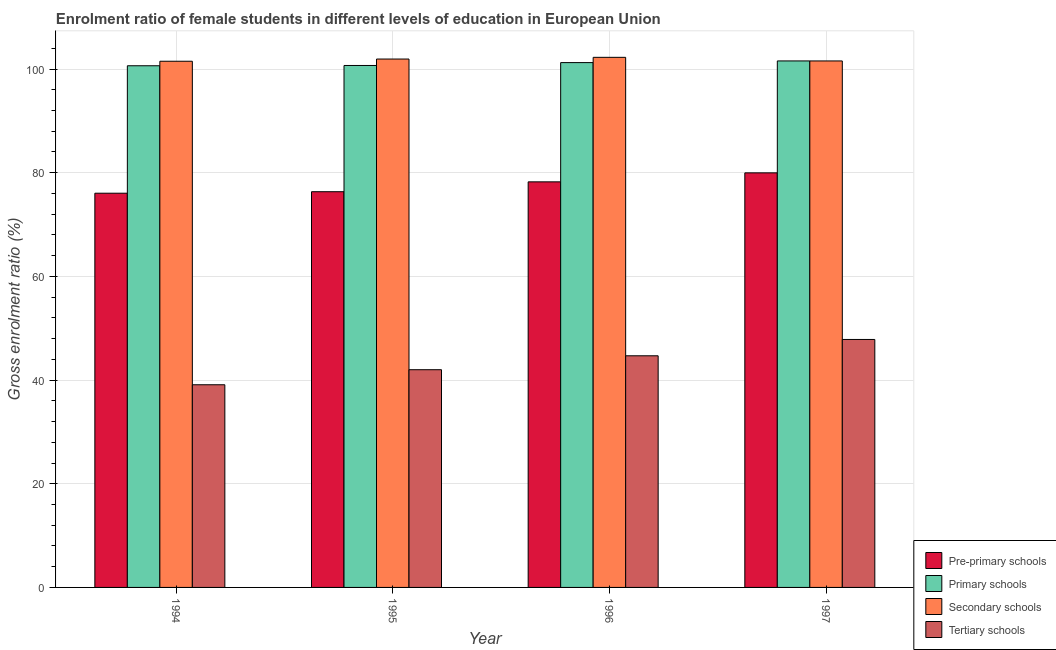How many different coloured bars are there?
Provide a short and direct response. 4. Are the number of bars per tick equal to the number of legend labels?
Provide a short and direct response. Yes. How many bars are there on the 1st tick from the right?
Offer a very short reply. 4. What is the label of the 2nd group of bars from the left?
Ensure brevity in your answer.  1995. In how many cases, is the number of bars for a given year not equal to the number of legend labels?
Make the answer very short. 0. What is the gross enrolment ratio(male) in secondary schools in 1996?
Make the answer very short. 102.26. Across all years, what is the maximum gross enrolment ratio(male) in pre-primary schools?
Offer a terse response. 79.97. Across all years, what is the minimum gross enrolment ratio(male) in pre-primary schools?
Offer a terse response. 76.05. What is the total gross enrolment ratio(male) in primary schools in the graph?
Give a very brief answer. 404.13. What is the difference between the gross enrolment ratio(male) in secondary schools in 1994 and that in 1996?
Ensure brevity in your answer.  -0.75. What is the difference between the gross enrolment ratio(male) in primary schools in 1994 and the gross enrolment ratio(male) in secondary schools in 1996?
Ensure brevity in your answer.  -0.61. What is the average gross enrolment ratio(male) in tertiary schools per year?
Provide a succinct answer. 43.4. In how many years, is the gross enrolment ratio(male) in tertiary schools greater than 76 %?
Offer a terse response. 0. What is the ratio of the gross enrolment ratio(male) in secondary schools in 1994 to that in 1996?
Offer a very short reply. 0.99. Is the gross enrolment ratio(male) in pre-primary schools in 1994 less than that in 1997?
Your answer should be very brief. Yes. Is the difference between the gross enrolment ratio(male) in primary schools in 1994 and 1995 greater than the difference between the gross enrolment ratio(male) in secondary schools in 1994 and 1995?
Your answer should be compact. No. What is the difference between the highest and the second highest gross enrolment ratio(male) in secondary schools?
Give a very brief answer. 0.33. What is the difference between the highest and the lowest gross enrolment ratio(male) in tertiary schools?
Offer a very short reply. 8.74. Is the sum of the gross enrolment ratio(male) in primary schools in 1994 and 1997 greater than the maximum gross enrolment ratio(male) in pre-primary schools across all years?
Provide a short and direct response. Yes. What does the 3rd bar from the left in 1995 represents?
Keep it short and to the point. Secondary schools. What does the 3rd bar from the right in 1994 represents?
Your answer should be compact. Primary schools. Are all the bars in the graph horizontal?
Ensure brevity in your answer.  No. How many years are there in the graph?
Provide a succinct answer. 4. What is the difference between two consecutive major ticks on the Y-axis?
Ensure brevity in your answer.  20. Does the graph contain grids?
Offer a terse response. Yes. Where does the legend appear in the graph?
Your answer should be very brief. Bottom right. How many legend labels are there?
Give a very brief answer. 4. What is the title of the graph?
Provide a short and direct response. Enrolment ratio of female students in different levels of education in European Union. Does "Regional development banks" appear as one of the legend labels in the graph?
Give a very brief answer. No. What is the label or title of the X-axis?
Keep it short and to the point. Year. What is the label or title of the Y-axis?
Offer a terse response. Gross enrolment ratio (%). What is the Gross enrolment ratio (%) in Pre-primary schools in 1994?
Provide a succinct answer. 76.05. What is the Gross enrolment ratio (%) in Primary schools in 1994?
Your answer should be compact. 100.63. What is the Gross enrolment ratio (%) in Secondary schools in 1994?
Your answer should be very brief. 101.51. What is the Gross enrolment ratio (%) of Tertiary schools in 1994?
Your answer should be compact. 39.1. What is the Gross enrolment ratio (%) in Pre-primary schools in 1995?
Ensure brevity in your answer.  76.34. What is the Gross enrolment ratio (%) of Primary schools in 1995?
Offer a very short reply. 100.69. What is the Gross enrolment ratio (%) of Secondary schools in 1995?
Your answer should be very brief. 101.93. What is the Gross enrolment ratio (%) of Tertiary schools in 1995?
Your response must be concise. 42. What is the Gross enrolment ratio (%) in Pre-primary schools in 1996?
Make the answer very short. 78.24. What is the Gross enrolment ratio (%) of Primary schools in 1996?
Give a very brief answer. 101.24. What is the Gross enrolment ratio (%) in Secondary schools in 1996?
Your answer should be very brief. 102.26. What is the Gross enrolment ratio (%) of Tertiary schools in 1996?
Provide a short and direct response. 44.68. What is the Gross enrolment ratio (%) in Pre-primary schools in 1997?
Give a very brief answer. 79.97. What is the Gross enrolment ratio (%) of Primary schools in 1997?
Your response must be concise. 101.57. What is the Gross enrolment ratio (%) in Secondary schools in 1997?
Give a very brief answer. 101.56. What is the Gross enrolment ratio (%) in Tertiary schools in 1997?
Your response must be concise. 47.83. Across all years, what is the maximum Gross enrolment ratio (%) in Pre-primary schools?
Keep it short and to the point. 79.97. Across all years, what is the maximum Gross enrolment ratio (%) in Primary schools?
Your response must be concise. 101.57. Across all years, what is the maximum Gross enrolment ratio (%) of Secondary schools?
Your response must be concise. 102.26. Across all years, what is the maximum Gross enrolment ratio (%) in Tertiary schools?
Ensure brevity in your answer.  47.83. Across all years, what is the minimum Gross enrolment ratio (%) in Pre-primary schools?
Provide a succinct answer. 76.05. Across all years, what is the minimum Gross enrolment ratio (%) in Primary schools?
Keep it short and to the point. 100.63. Across all years, what is the minimum Gross enrolment ratio (%) in Secondary schools?
Offer a terse response. 101.51. Across all years, what is the minimum Gross enrolment ratio (%) in Tertiary schools?
Keep it short and to the point. 39.1. What is the total Gross enrolment ratio (%) in Pre-primary schools in the graph?
Offer a very short reply. 310.6. What is the total Gross enrolment ratio (%) of Primary schools in the graph?
Offer a very short reply. 404.13. What is the total Gross enrolment ratio (%) of Secondary schools in the graph?
Your answer should be compact. 407.26. What is the total Gross enrolment ratio (%) of Tertiary schools in the graph?
Your answer should be very brief. 173.61. What is the difference between the Gross enrolment ratio (%) in Pre-primary schools in 1994 and that in 1995?
Your response must be concise. -0.29. What is the difference between the Gross enrolment ratio (%) of Primary schools in 1994 and that in 1995?
Make the answer very short. -0.05. What is the difference between the Gross enrolment ratio (%) in Secondary schools in 1994 and that in 1995?
Your answer should be very brief. -0.42. What is the difference between the Gross enrolment ratio (%) in Tertiary schools in 1994 and that in 1995?
Provide a succinct answer. -2.9. What is the difference between the Gross enrolment ratio (%) in Pre-primary schools in 1994 and that in 1996?
Your response must be concise. -2.19. What is the difference between the Gross enrolment ratio (%) in Primary schools in 1994 and that in 1996?
Your answer should be compact. -0.61. What is the difference between the Gross enrolment ratio (%) in Secondary schools in 1994 and that in 1996?
Keep it short and to the point. -0.75. What is the difference between the Gross enrolment ratio (%) of Tertiary schools in 1994 and that in 1996?
Offer a terse response. -5.59. What is the difference between the Gross enrolment ratio (%) in Pre-primary schools in 1994 and that in 1997?
Your response must be concise. -3.93. What is the difference between the Gross enrolment ratio (%) in Primary schools in 1994 and that in 1997?
Ensure brevity in your answer.  -0.93. What is the difference between the Gross enrolment ratio (%) in Secondary schools in 1994 and that in 1997?
Make the answer very short. -0.06. What is the difference between the Gross enrolment ratio (%) in Tertiary schools in 1994 and that in 1997?
Your response must be concise. -8.74. What is the difference between the Gross enrolment ratio (%) of Pre-primary schools in 1995 and that in 1996?
Offer a very short reply. -1.9. What is the difference between the Gross enrolment ratio (%) in Primary schools in 1995 and that in 1996?
Provide a short and direct response. -0.56. What is the difference between the Gross enrolment ratio (%) of Secondary schools in 1995 and that in 1996?
Your answer should be compact. -0.33. What is the difference between the Gross enrolment ratio (%) of Tertiary schools in 1995 and that in 1996?
Provide a short and direct response. -2.68. What is the difference between the Gross enrolment ratio (%) in Pre-primary schools in 1995 and that in 1997?
Provide a short and direct response. -3.64. What is the difference between the Gross enrolment ratio (%) in Primary schools in 1995 and that in 1997?
Keep it short and to the point. -0.88. What is the difference between the Gross enrolment ratio (%) in Secondary schools in 1995 and that in 1997?
Your answer should be very brief. 0.37. What is the difference between the Gross enrolment ratio (%) of Tertiary schools in 1995 and that in 1997?
Ensure brevity in your answer.  -5.83. What is the difference between the Gross enrolment ratio (%) in Pre-primary schools in 1996 and that in 1997?
Keep it short and to the point. -1.73. What is the difference between the Gross enrolment ratio (%) in Primary schools in 1996 and that in 1997?
Offer a terse response. -0.32. What is the difference between the Gross enrolment ratio (%) in Secondary schools in 1996 and that in 1997?
Offer a terse response. 0.7. What is the difference between the Gross enrolment ratio (%) of Tertiary schools in 1996 and that in 1997?
Ensure brevity in your answer.  -3.15. What is the difference between the Gross enrolment ratio (%) of Pre-primary schools in 1994 and the Gross enrolment ratio (%) of Primary schools in 1995?
Provide a short and direct response. -24.64. What is the difference between the Gross enrolment ratio (%) in Pre-primary schools in 1994 and the Gross enrolment ratio (%) in Secondary schools in 1995?
Offer a terse response. -25.88. What is the difference between the Gross enrolment ratio (%) in Pre-primary schools in 1994 and the Gross enrolment ratio (%) in Tertiary schools in 1995?
Ensure brevity in your answer.  34.05. What is the difference between the Gross enrolment ratio (%) in Primary schools in 1994 and the Gross enrolment ratio (%) in Secondary schools in 1995?
Provide a succinct answer. -1.3. What is the difference between the Gross enrolment ratio (%) of Primary schools in 1994 and the Gross enrolment ratio (%) of Tertiary schools in 1995?
Your answer should be very brief. 58.63. What is the difference between the Gross enrolment ratio (%) in Secondary schools in 1994 and the Gross enrolment ratio (%) in Tertiary schools in 1995?
Ensure brevity in your answer.  59.51. What is the difference between the Gross enrolment ratio (%) of Pre-primary schools in 1994 and the Gross enrolment ratio (%) of Primary schools in 1996?
Make the answer very short. -25.2. What is the difference between the Gross enrolment ratio (%) in Pre-primary schools in 1994 and the Gross enrolment ratio (%) in Secondary schools in 1996?
Keep it short and to the point. -26.21. What is the difference between the Gross enrolment ratio (%) of Pre-primary schools in 1994 and the Gross enrolment ratio (%) of Tertiary schools in 1996?
Offer a very short reply. 31.36. What is the difference between the Gross enrolment ratio (%) in Primary schools in 1994 and the Gross enrolment ratio (%) in Secondary schools in 1996?
Keep it short and to the point. -1.63. What is the difference between the Gross enrolment ratio (%) in Primary schools in 1994 and the Gross enrolment ratio (%) in Tertiary schools in 1996?
Your answer should be compact. 55.95. What is the difference between the Gross enrolment ratio (%) of Secondary schools in 1994 and the Gross enrolment ratio (%) of Tertiary schools in 1996?
Make the answer very short. 56.82. What is the difference between the Gross enrolment ratio (%) in Pre-primary schools in 1994 and the Gross enrolment ratio (%) in Primary schools in 1997?
Keep it short and to the point. -25.52. What is the difference between the Gross enrolment ratio (%) in Pre-primary schools in 1994 and the Gross enrolment ratio (%) in Secondary schools in 1997?
Provide a short and direct response. -25.51. What is the difference between the Gross enrolment ratio (%) of Pre-primary schools in 1994 and the Gross enrolment ratio (%) of Tertiary schools in 1997?
Provide a succinct answer. 28.21. What is the difference between the Gross enrolment ratio (%) in Primary schools in 1994 and the Gross enrolment ratio (%) in Secondary schools in 1997?
Ensure brevity in your answer.  -0.93. What is the difference between the Gross enrolment ratio (%) of Primary schools in 1994 and the Gross enrolment ratio (%) of Tertiary schools in 1997?
Give a very brief answer. 52.8. What is the difference between the Gross enrolment ratio (%) of Secondary schools in 1994 and the Gross enrolment ratio (%) of Tertiary schools in 1997?
Provide a short and direct response. 53.67. What is the difference between the Gross enrolment ratio (%) in Pre-primary schools in 1995 and the Gross enrolment ratio (%) in Primary schools in 1996?
Keep it short and to the point. -24.91. What is the difference between the Gross enrolment ratio (%) of Pre-primary schools in 1995 and the Gross enrolment ratio (%) of Secondary schools in 1996?
Offer a terse response. -25.92. What is the difference between the Gross enrolment ratio (%) in Pre-primary schools in 1995 and the Gross enrolment ratio (%) in Tertiary schools in 1996?
Give a very brief answer. 31.65. What is the difference between the Gross enrolment ratio (%) of Primary schools in 1995 and the Gross enrolment ratio (%) of Secondary schools in 1996?
Give a very brief answer. -1.57. What is the difference between the Gross enrolment ratio (%) in Primary schools in 1995 and the Gross enrolment ratio (%) in Tertiary schools in 1996?
Give a very brief answer. 56. What is the difference between the Gross enrolment ratio (%) in Secondary schools in 1995 and the Gross enrolment ratio (%) in Tertiary schools in 1996?
Ensure brevity in your answer.  57.25. What is the difference between the Gross enrolment ratio (%) in Pre-primary schools in 1995 and the Gross enrolment ratio (%) in Primary schools in 1997?
Offer a terse response. -25.23. What is the difference between the Gross enrolment ratio (%) of Pre-primary schools in 1995 and the Gross enrolment ratio (%) of Secondary schools in 1997?
Offer a very short reply. -25.23. What is the difference between the Gross enrolment ratio (%) of Pre-primary schools in 1995 and the Gross enrolment ratio (%) of Tertiary schools in 1997?
Your answer should be compact. 28.5. What is the difference between the Gross enrolment ratio (%) of Primary schools in 1995 and the Gross enrolment ratio (%) of Secondary schools in 1997?
Your answer should be compact. -0.87. What is the difference between the Gross enrolment ratio (%) in Primary schools in 1995 and the Gross enrolment ratio (%) in Tertiary schools in 1997?
Offer a very short reply. 52.85. What is the difference between the Gross enrolment ratio (%) of Secondary schools in 1995 and the Gross enrolment ratio (%) of Tertiary schools in 1997?
Offer a terse response. 54.1. What is the difference between the Gross enrolment ratio (%) in Pre-primary schools in 1996 and the Gross enrolment ratio (%) in Primary schools in 1997?
Your answer should be very brief. -23.33. What is the difference between the Gross enrolment ratio (%) in Pre-primary schools in 1996 and the Gross enrolment ratio (%) in Secondary schools in 1997?
Your answer should be compact. -23.32. What is the difference between the Gross enrolment ratio (%) of Pre-primary schools in 1996 and the Gross enrolment ratio (%) of Tertiary schools in 1997?
Provide a short and direct response. 30.41. What is the difference between the Gross enrolment ratio (%) in Primary schools in 1996 and the Gross enrolment ratio (%) in Secondary schools in 1997?
Provide a short and direct response. -0.32. What is the difference between the Gross enrolment ratio (%) of Primary schools in 1996 and the Gross enrolment ratio (%) of Tertiary schools in 1997?
Keep it short and to the point. 53.41. What is the difference between the Gross enrolment ratio (%) in Secondary schools in 1996 and the Gross enrolment ratio (%) in Tertiary schools in 1997?
Your answer should be compact. 54.43. What is the average Gross enrolment ratio (%) of Pre-primary schools per year?
Your answer should be very brief. 77.65. What is the average Gross enrolment ratio (%) in Primary schools per year?
Provide a succinct answer. 101.03. What is the average Gross enrolment ratio (%) of Secondary schools per year?
Make the answer very short. 101.82. What is the average Gross enrolment ratio (%) of Tertiary schools per year?
Provide a short and direct response. 43.4. In the year 1994, what is the difference between the Gross enrolment ratio (%) of Pre-primary schools and Gross enrolment ratio (%) of Primary schools?
Give a very brief answer. -24.59. In the year 1994, what is the difference between the Gross enrolment ratio (%) in Pre-primary schools and Gross enrolment ratio (%) in Secondary schools?
Your answer should be compact. -25.46. In the year 1994, what is the difference between the Gross enrolment ratio (%) in Pre-primary schools and Gross enrolment ratio (%) in Tertiary schools?
Provide a succinct answer. 36.95. In the year 1994, what is the difference between the Gross enrolment ratio (%) in Primary schools and Gross enrolment ratio (%) in Secondary schools?
Your answer should be very brief. -0.87. In the year 1994, what is the difference between the Gross enrolment ratio (%) in Primary schools and Gross enrolment ratio (%) in Tertiary schools?
Offer a terse response. 61.54. In the year 1994, what is the difference between the Gross enrolment ratio (%) of Secondary schools and Gross enrolment ratio (%) of Tertiary schools?
Ensure brevity in your answer.  62.41. In the year 1995, what is the difference between the Gross enrolment ratio (%) in Pre-primary schools and Gross enrolment ratio (%) in Primary schools?
Provide a short and direct response. -24.35. In the year 1995, what is the difference between the Gross enrolment ratio (%) of Pre-primary schools and Gross enrolment ratio (%) of Secondary schools?
Provide a succinct answer. -25.6. In the year 1995, what is the difference between the Gross enrolment ratio (%) of Pre-primary schools and Gross enrolment ratio (%) of Tertiary schools?
Make the answer very short. 34.34. In the year 1995, what is the difference between the Gross enrolment ratio (%) in Primary schools and Gross enrolment ratio (%) in Secondary schools?
Your answer should be very brief. -1.24. In the year 1995, what is the difference between the Gross enrolment ratio (%) of Primary schools and Gross enrolment ratio (%) of Tertiary schools?
Give a very brief answer. 58.69. In the year 1995, what is the difference between the Gross enrolment ratio (%) in Secondary schools and Gross enrolment ratio (%) in Tertiary schools?
Provide a short and direct response. 59.93. In the year 1996, what is the difference between the Gross enrolment ratio (%) of Pre-primary schools and Gross enrolment ratio (%) of Primary schools?
Your answer should be compact. -23. In the year 1996, what is the difference between the Gross enrolment ratio (%) in Pre-primary schools and Gross enrolment ratio (%) in Secondary schools?
Your answer should be very brief. -24.02. In the year 1996, what is the difference between the Gross enrolment ratio (%) of Pre-primary schools and Gross enrolment ratio (%) of Tertiary schools?
Offer a terse response. 33.56. In the year 1996, what is the difference between the Gross enrolment ratio (%) in Primary schools and Gross enrolment ratio (%) in Secondary schools?
Ensure brevity in your answer.  -1.02. In the year 1996, what is the difference between the Gross enrolment ratio (%) in Primary schools and Gross enrolment ratio (%) in Tertiary schools?
Your response must be concise. 56.56. In the year 1996, what is the difference between the Gross enrolment ratio (%) of Secondary schools and Gross enrolment ratio (%) of Tertiary schools?
Give a very brief answer. 57.58. In the year 1997, what is the difference between the Gross enrolment ratio (%) in Pre-primary schools and Gross enrolment ratio (%) in Primary schools?
Ensure brevity in your answer.  -21.59. In the year 1997, what is the difference between the Gross enrolment ratio (%) in Pre-primary schools and Gross enrolment ratio (%) in Secondary schools?
Your answer should be compact. -21.59. In the year 1997, what is the difference between the Gross enrolment ratio (%) of Pre-primary schools and Gross enrolment ratio (%) of Tertiary schools?
Your answer should be compact. 32.14. In the year 1997, what is the difference between the Gross enrolment ratio (%) in Primary schools and Gross enrolment ratio (%) in Secondary schools?
Keep it short and to the point. 0. In the year 1997, what is the difference between the Gross enrolment ratio (%) in Primary schools and Gross enrolment ratio (%) in Tertiary schools?
Ensure brevity in your answer.  53.73. In the year 1997, what is the difference between the Gross enrolment ratio (%) in Secondary schools and Gross enrolment ratio (%) in Tertiary schools?
Give a very brief answer. 53.73. What is the ratio of the Gross enrolment ratio (%) of Pre-primary schools in 1994 to that in 1995?
Your response must be concise. 1. What is the ratio of the Gross enrolment ratio (%) in Secondary schools in 1994 to that in 1995?
Your response must be concise. 1. What is the ratio of the Gross enrolment ratio (%) of Tertiary schools in 1994 to that in 1995?
Give a very brief answer. 0.93. What is the ratio of the Gross enrolment ratio (%) of Pre-primary schools in 1994 to that in 1996?
Your answer should be very brief. 0.97. What is the ratio of the Gross enrolment ratio (%) in Primary schools in 1994 to that in 1996?
Offer a terse response. 0.99. What is the ratio of the Gross enrolment ratio (%) in Tertiary schools in 1994 to that in 1996?
Your answer should be compact. 0.87. What is the ratio of the Gross enrolment ratio (%) in Pre-primary schools in 1994 to that in 1997?
Your response must be concise. 0.95. What is the ratio of the Gross enrolment ratio (%) in Primary schools in 1994 to that in 1997?
Keep it short and to the point. 0.99. What is the ratio of the Gross enrolment ratio (%) in Secondary schools in 1994 to that in 1997?
Ensure brevity in your answer.  1. What is the ratio of the Gross enrolment ratio (%) in Tertiary schools in 1994 to that in 1997?
Offer a very short reply. 0.82. What is the ratio of the Gross enrolment ratio (%) in Pre-primary schools in 1995 to that in 1996?
Your answer should be very brief. 0.98. What is the ratio of the Gross enrolment ratio (%) in Secondary schools in 1995 to that in 1996?
Provide a short and direct response. 1. What is the ratio of the Gross enrolment ratio (%) in Tertiary schools in 1995 to that in 1996?
Your answer should be compact. 0.94. What is the ratio of the Gross enrolment ratio (%) of Pre-primary schools in 1995 to that in 1997?
Give a very brief answer. 0.95. What is the ratio of the Gross enrolment ratio (%) of Tertiary schools in 1995 to that in 1997?
Ensure brevity in your answer.  0.88. What is the ratio of the Gross enrolment ratio (%) in Pre-primary schools in 1996 to that in 1997?
Provide a short and direct response. 0.98. What is the ratio of the Gross enrolment ratio (%) in Secondary schools in 1996 to that in 1997?
Your response must be concise. 1.01. What is the ratio of the Gross enrolment ratio (%) of Tertiary schools in 1996 to that in 1997?
Make the answer very short. 0.93. What is the difference between the highest and the second highest Gross enrolment ratio (%) of Pre-primary schools?
Your answer should be compact. 1.73. What is the difference between the highest and the second highest Gross enrolment ratio (%) of Primary schools?
Provide a short and direct response. 0.32. What is the difference between the highest and the second highest Gross enrolment ratio (%) of Secondary schools?
Your response must be concise. 0.33. What is the difference between the highest and the second highest Gross enrolment ratio (%) of Tertiary schools?
Your answer should be compact. 3.15. What is the difference between the highest and the lowest Gross enrolment ratio (%) in Pre-primary schools?
Provide a short and direct response. 3.93. What is the difference between the highest and the lowest Gross enrolment ratio (%) of Primary schools?
Provide a short and direct response. 0.93. What is the difference between the highest and the lowest Gross enrolment ratio (%) of Secondary schools?
Keep it short and to the point. 0.75. What is the difference between the highest and the lowest Gross enrolment ratio (%) of Tertiary schools?
Your response must be concise. 8.74. 